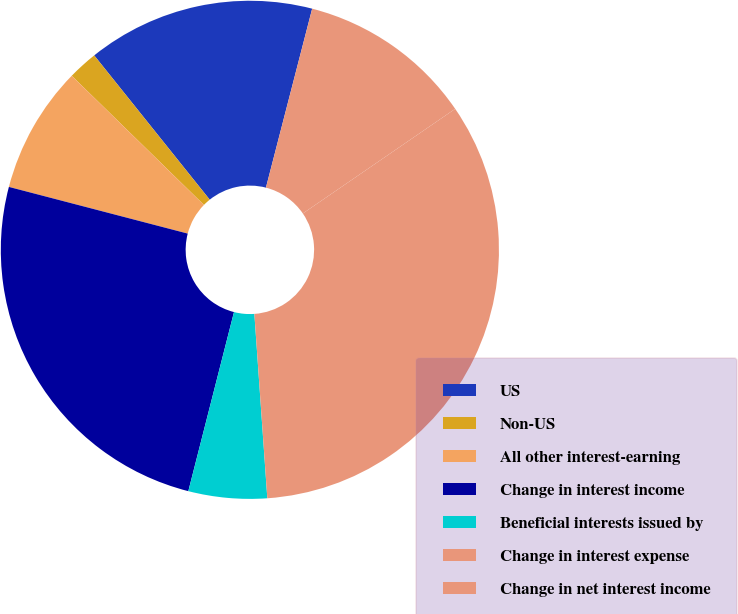Convert chart. <chart><loc_0><loc_0><loc_500><loc_500><pie_chart><fcel>US<fcel>Non-US<fcel>All other interest-earning<fcel>Change in interest income<fcel>Beneficial interests issued by<fcel>Change in interest expense<fcel>Change in net interest income<nl><fcel>14.77%<fcel>1.94%<fcel>8.25%<fcel>25.09%<fcel>5.09%<fcel>33.46%<fcel>11.4%<nl></chart> 